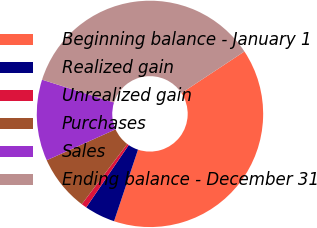Convert chart. <chart><loc_0><loc_0><loc_500><loc_500><pie_chart><fcel>Beginning balance - January 1<fcel>Realized gain<fcel>Unrealized gain<fcel>Purchases<fcel>Sales<fcel>Ending balance - December 31<nl><fcel>39.43%<fcel>4.38%<fcel>0.77%<fcel>7.99%<fcel>11.6%<fcel>35.82%<nl></chart> 